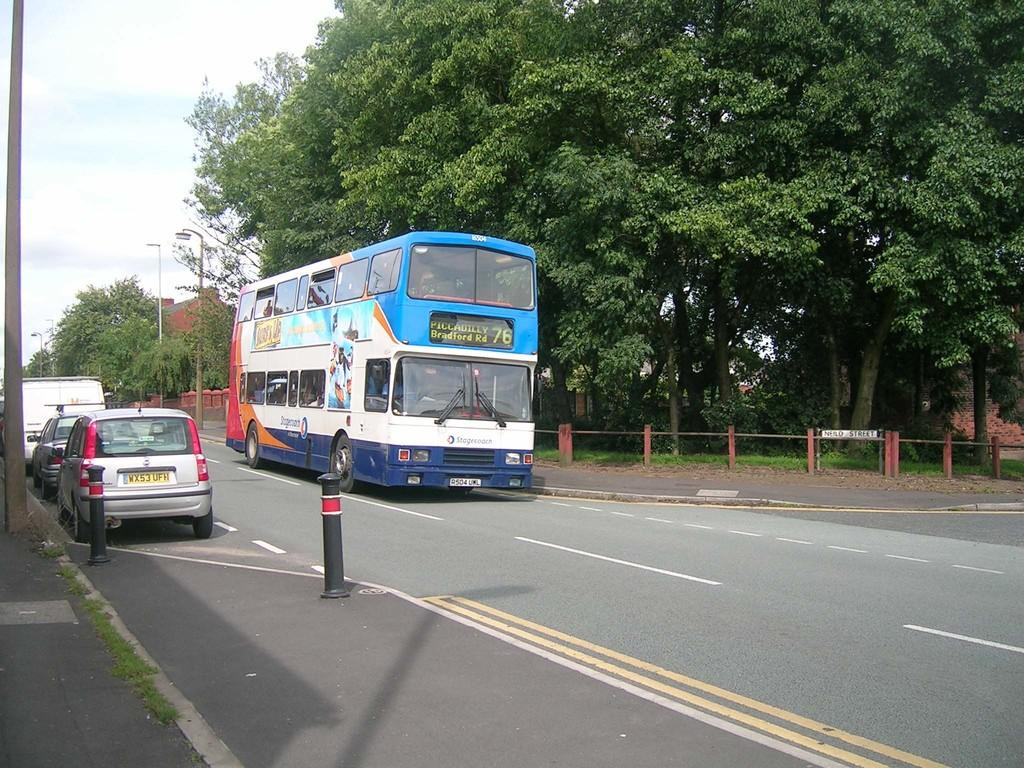What can be seen on the road in the image? There are vehicles on the road in the image. What type of natural elements are visible in the image? Trees are visible in the image. What type of lighting is present in the image? Pole lights are present in the image. What type of barrier is present in the image? There is a metal fence in the image. What can be seen in the sky in the image? Clouds are visible in the sky in the image. Where are your friends mining in the image? There are no friends or mining activities present in the image. What type of writing instrument is being used by the quill in the image? There is no quill present in the image. 